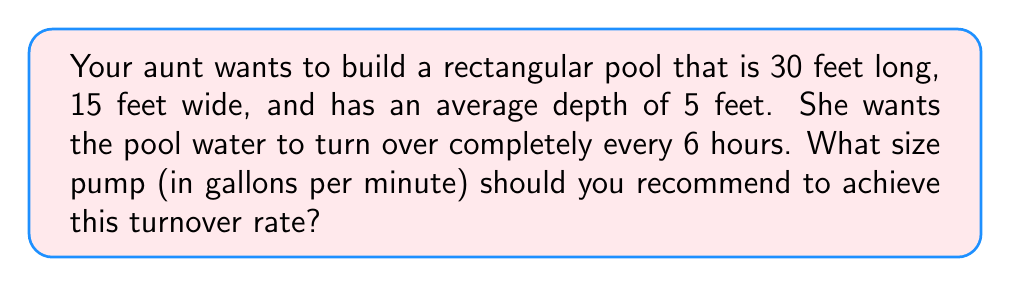Show me your answer to this math problem. Let's approach this step-by-step:

1) First, we need to calculate the volume of the pool:
   Volume = Length × Width × Average Depth
   $$ V = 30 \text{ ft} \times 15 \text{ ft} \times 5 \text{ ft} = 2,250 \text{ ft}^3 $$

2) Convert cubic feet to gallons:
   1 cubic foot = 7.48052 gallons
   $$ 2,250 \text{ ft}^3 \times 7.48052 \text{ gal/ft}^3 = 16,831.17 \text{ gallons} $$

3) The turnover rate is every 6 hours, so we need to pump this entire volume in 6 hours.

4) To find gallons per minute (GPM), we divide the total volume by the number of minutes in 6 hours:
   $$ \text{GPM} = \frac{16,831.17 \text{ gallons}}{6 \text{ hours} \times 60 \text{ min/hour}} $$

5) Simplify:
   $$ \text{GPM} = \frac{16,831.17}{360} = 46.75 \text{ GPM} $$

6) Round up to the nearest whole number for practical pump sizing.
Answer: The recommended pump size is 47 GPM (gallons per minute). 